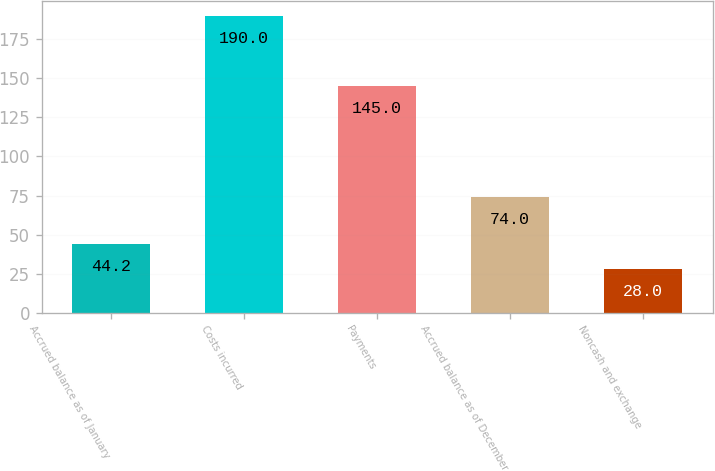Convert chart to OTSL. <chart><loc_0><loc_0><loc_500><loc_500><bar_chart><fcel>Accrued balance as of January<fcel>Costs incurred<fcel>Payments<fcel>Accrued balance as of December<fcel>Noncash and exchange<nl><fcel>44.2<fcel>190<fcel>145<fcel>74<fcel>28<nl></chart> 